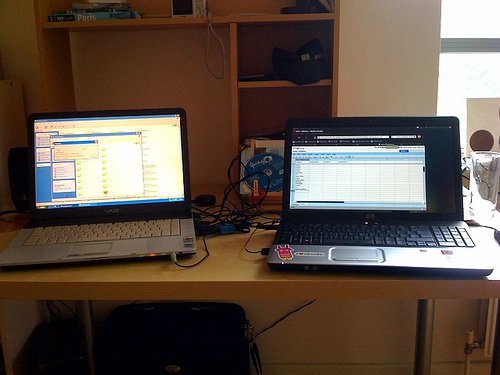Describe the objects in this image and their specific colors. I can see laptop in maroon, black, white, lightblue, and darkgray tones, laptop in maroon, beige, black, and gray tones, keyboard in maroon, black, white, gray, and darkgray tones, suitcase in black and maroon tones, and keyboard in maroon, gray, and black tones in this image. 